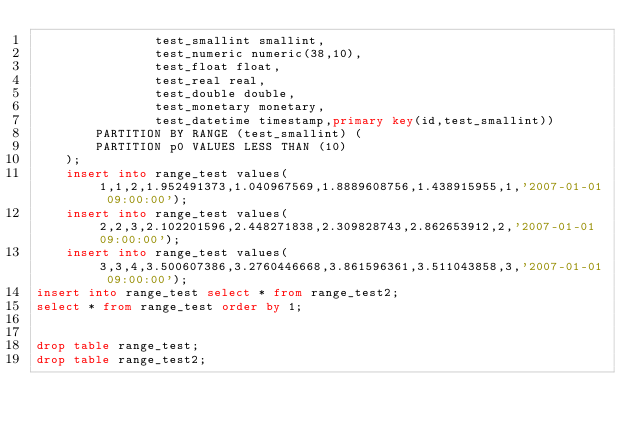Convert code to text. <code><loc_0><loc_0><loc_500><loc_500><_SQL_>				test_smallint smallint,
				test_numeric numeric(38,10),
				test_float float,
				test_real real,
				test_double double,
				test_monetary monetary,
				test_datetime timestamp,primary key(id,test_smallint))
		PARTITION BY RANGE (test_smallint) (
		PARTITION p0 VALUES LESS THAN (10)
	);
	insert into range_test values( 1,1,2,1.952491373,1.040967569,1.8889608756,1.438915955,1,'2007-01-01 09:00:00');
	insert into range_test values( 2,2,3,2.102201596,2.448271838,2.309828743,2.862653912,2,'2007-01-01 09:00:00');
	insert into range_test values( 3,3,4,3.500607386,3.2760446668,3.861596361,3.511043858,3,'2007-01-01 09:00:00');
insert into range_test select * from range_test2;
select * from range_test order by 1;


drop table range_test;
drop table range_test2;
</code> 